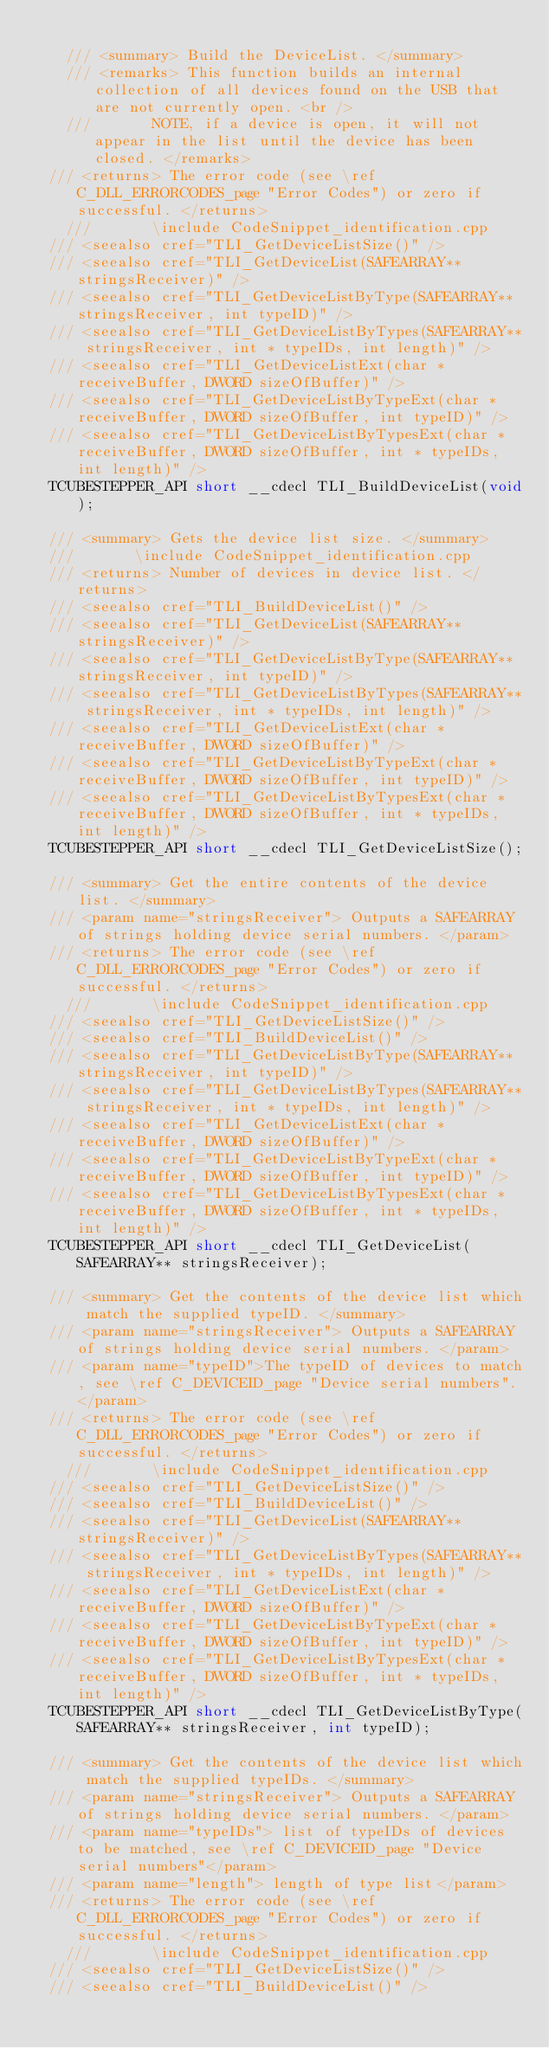<code> <loc_0><loc_0><loc_500><loc_500><_C_>
    /// <summary> Build the DeviceList. </summary>
    /// <remarks> This function builds an internal collection of all devices found on the USB that are not currently open. <br />
    /// 		  NOTE, if a device is open, it will not appear in the list until the device has been closed. </remarks>
	/// <returns> The error code (see \ref C_DLL_ERRORCODES_page "Error Codes") or zero if successful. </returns>
    /// 		  \include CodeSnippet_identification.cpp
	/// <seealso cref="TLI_GetDeviceListSize()" />
	/// <seealso cref="TLI_GetDeviceList(SAFEARRAY** stringsReceiver)" />
	/// <seealso cref="TLI_GetDeviceListByType(SAFEARRAY** stringsReceiver, int typeID)" />
	/// <seealso cref="TLI_GetDeviceListByTypes(SAFEARRAY** stringsReceiver, int * typeIDs, int length)" />
	/// <seealso cref="TLI_GetDeviceListExt(char *receiveBuffer, DWORD sizeOfBuffer)" />
	/// <seealso cref="TLI_GetDeviceListByTypeExt(char *receiveBuffer, DWORD sizeOfBuffer, int typeID)" />
	/// <seealso cref="TLI_GetDeviceListByTypesExt(char *receiveBuffer, DWORD sizeOfBuffer, int * typeIDs, int length)" />
	TCUBESTEPPER_API short __cdecl TLI_BuildDeviceList(void);

	/// <summary> Gets the device list size. </summary>
	/// 		  \include CodeSnippet_identification.cpp
	/// <returns> Number of devices in device list. </returns>
	/// <seealso cref="TLI_BuildDeviceList()" />
	/// <seealso cref="TLI_GetDeviceList(SAFEARRAY** stringsReceiver)" />
	/// <seealso cref="TLI_GetDeviceListByType(SAFEARRAY** stringsReceiver, int typeID)" />
	/// <seealso cref="TLI_GetDeviceListByTypes(SAFEARRAY** stringsReceiver, int * typeIDs, int length)" />
	/// <seealso cref="TLI_GetDeviceListExt(char *receiveBuffer, DWORD sizeOfBuffer)" />
	/// <seealso cref="TLI_GetDeviceListByTypeExt(char *receiveBuffer, DWORD sizeOfBuffer, int typeID)" />
	/// <seealso cref="TLI_GetDeviceListByTypesExt(char *receiveBuffer, DWORD sizeOfBuffer, int * typeIDs, int length)" />
	TCUBESTEPPER_API short __cdecl TLI_GetDeviceListSize();

	/// <summary> Get the entire contents of the device list. </summary>
	/// <param name="stringsReceiver"> Outputs a SAFEARRAY of strings holding device serial numbers. </param>
	/// <returns> The error code (see \ref C_DLL_ERRORCODES_page "Error Codes") or zero if successful. </returns>
    /// 		  \include CodeSnippet_identification.cpp
	/// <seealso cref="TLI_GetDeviceListSize()" />
	/// <seealso cref="TLI_BuildDeviceList()" />
	/// <seealso cref="TLI_GetDeviceListByType(SAFEARRAY** stringsReceiver, int typeID)" />
	/// <seealso cref="TLI_GetDeviceListByTypes(SAFEARRAY** stringsReceiver, int * typeIDs, int length)" />
	/// <seealso cref="TLI_GetDeviceListExt(char *receiveBuffer, DWORD sizeOfBuffer)" />
	/// <seealso cref="TLI_GetDeviceListByTypeExt(char *receiveBuffer, DWORD sizeOfBuffer, int typeID)" />
	/// <seealso cref="TLI_GetDeviceListByTypesExt(char *receiveBuffer, DWORD sizeOfBuffer, int * typeIDs, int length)" />
	TCUBESTEPPER_API short __cdecl TLI_GetDeviceList(SAFEARRAY** stringsReceiver);

	/// <summary> Get the contents of the device list which match the supplied typeID. </summary>
	/// <param name="stringsReceiver"> Outputs a SAFEARRAY of strings holding device serial numbers. </param>
	/// <param name="typeID">The typeID of devices to match, see \ref C_DEVICEID_page "Device serial numbers". </param>
	/// <returns> The error code (see \ref C_DLL_ERRORCODES_page "Error Codes") or zero if successful. </returns>
    /// 		  \include CodeSnippet_identification.cpp
	/// <seealso cref="TLI_GetDeviceListSize()" />
	/// <seealso cref="TLI_BuildDeviceList()" />
	/// <seealso cref="TLI_GetDeviceList(SAFEARRAY** stringsReceiver)" />
	/// <seealso cref="TLI_GetDeviceListByTypes(SAFEARRAY** stringsReceiver, int * typeIDs, int length)" />
	/// <seealso cref="TLI_GetDeviceListExt(char *receiveBuffer, DWORD sizeOfBuffer)" />
	/// <seealso cref="TLI_GetDeviceListByTypeExt(char *receiveBuffer, DWORD sizeOfBuffer, int typeID)" />
	/// <seealso cref="TLI_GetDeviceListByTypesExt(char *receiveBuffer, DWORD sizeOfBuffer, int * typeIDs, int length)" />
	TCUBESTEPPER_API short __cdecl TLI_GetDeviceListByType(SAFEARRAY** stringsReceiver, int typeID);

	/// <summary> Get the contents of the device list which match the supplied typeIDs. </summary>
	/// <param name="stringsReceiver"> Outputs a SAFEARRAY of strings holding device serial numbers. </param>
	/// <param name="typeIDs"> list of typeIDs of devices to be matched, see \ref C_DEVICEID_page "Device serial numbers"</param>
	/// <param name="length"> length of type list</param>
	/// <returns> The error code (see \ref C_DLL_ERRORCODES_page "Error Codes") or zero if successful. </returns>
    /// 		  \include CodeSnippet_identification.cpp
	/// <seealso cref="TLI_GetDeviceListSize()" />
	/// <seealso cref="TLI_BuildDeviceList()" /></code> 